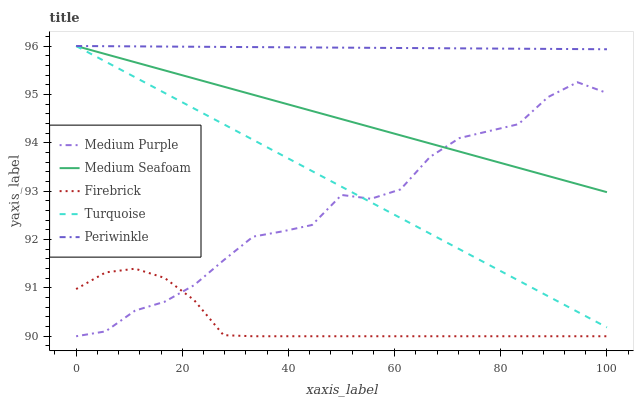Does Firebrick have the minimum area under the curve?
Answer yes or no. Yes. Does Periwinkle have the maximum area under the curve?
Answer yes or no. Yes. Does Turquoise have the minimum area under the curve?
Answer yes or no. No. Does Turquoise have the maximum area under the curve?
Answer yes or no. No. Is Medium Seafoam the smoothest?
Answer yes or no. Yes. Is Medium Purple the roughest?
Answer yes or no. Yes. Is Firebrick the smoothest?
Answer yes or no. No. Is Firebrick the roughest?
Answer yes or no. No. Does Medium Purple have the lowest value?
Answer yes or no. Yes. Does Turquoise have the lowest value?
Answer yes or no. No. Does Medium Seafoam have the highest value?
Answer yes or no. Yes. Does Firebrick have the highest value?
Answer yes or no. No. Is Firebrick less than Periwinkle?
Answer yes or no. Yes. Is Medium Seafoam greater than Firebrick?
Answer yes or no. Yes. Does Periwinkle intersect Turquoise?
Answer yes or no. Yes. Is Periwinkle less than Turquoise?
Answer yes or no. No. Is Periwinkle greater than Turquoise?
Answer yes or no. No. Does Firebrick intersect Periwinkle?
Answer yes or no. No. 